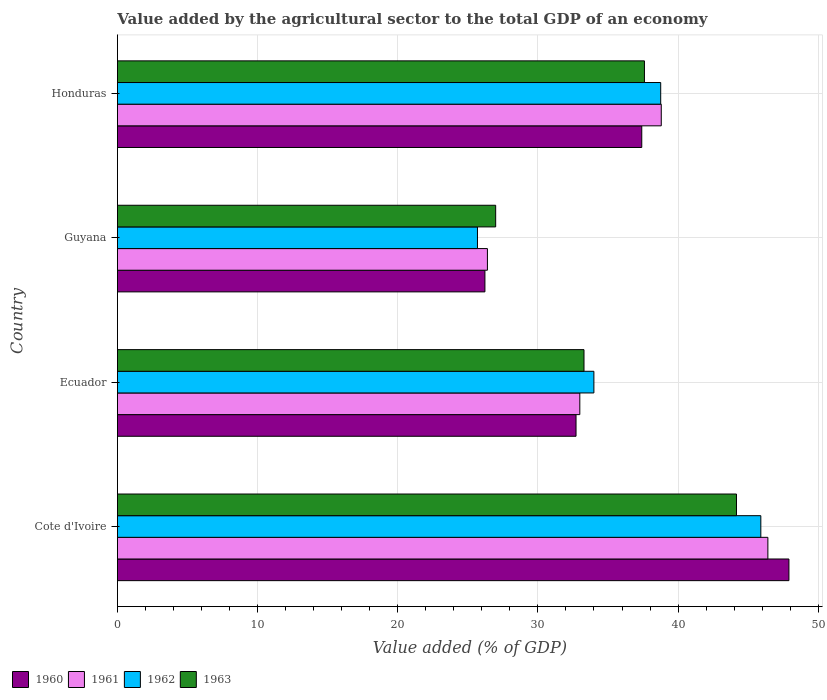How many groups of bars are there?
Ensure brevity in your answer.  4. Are the number of bars per tick equal to the number of legend labels?
Keep it short and to the point. Yes. How many bars are there on the 2nd tick from the top?
Give a very brief answer. 4. What is the label of the 4th group of bars from the top?
Ensure brevity in your answer.  Cote d'Ivoire. What is the value added by the agricultural sector to the total GDP in 1963 in Cote d'Ivoire?
Offer a very short reply. 44.17. Across all countries, what is the maximum value added by the agricultural sector to the total GDP in 1960?
Give a very brief answer. 47.91. Across all countries, what is the minimum value added by the agricultural sector to the total GDP in 1962?
Keep it short and to the point. 25.69. In which country was the value added by the agricultural sector to the total GDP in 1961 maximum?
Your answer should be compact. Cote d'Ivoire. In which country was the value added by the agricultural sector to the total GDP in 1960 minimum?
Your answer should be compact. Guyana. What is the total value added by the agricultural sector to the total GDP in 1963 in the graph?
Make the answer very short. 142.04. What is the difference between the value added by the agricultural sector to the total GDP in 1961 in Cote d'Ivoire and that in Honduras?
Your answer should be very brief. 7.61. What is the difference between the value added by the agricultural sector to the total GDP in 1960 in Honduras and the value added by the agricultural sector to the total GDP in 1963 in Ecuador?
Offer a very short reply. 4.12. What is the average value added by the agricultural sector to the total GDP in 1961 per country?
Offer a terse response. 36.15. What is the difference between the value added by the agricultural sector to the total GDP in 1963 and value added by the agricultural sector to the total GDP in 1962 in Ecuador?
Provide a succinct answer. -0.71. What is the ratio of the value added by the agricultural sector to the total GDP in 1962 in Cote d'Ivoire to that in Ecuador?
Provide a succinct answer. 1.35. Is the value added by the agricultural sector to the total GDP in 1962 in Guyana less than that in Honduras?
Provide a succinct answer. Yes. What is the difference between the highest and the second highest value added by the agricultural sector to the total GDP in 1960?
Your answer should be compact. 10.5. What is the difference between the highest and the lowest value added by the agricultural sector to the total GDP in 1963?
Give a very brief answer. 17.18. Is the sum of the value added by the agricultural sector to the total GDP in 1962 in Cote d'Ivoire and Honduras greater than the maximum value added by the agricultural sector to the total GDP in 1960 across all countries?
Make the answer very short. Yes. Is it the case that in every country, the sum of the value added by the agricultural sector to the total GDP in 1962 and value added by the agricultural sector to the total GDP in 1961 is greater than the sum of value added by the agricultural sector to the total GDP in 1963 and value added by the agricultural sector to the total GDP in 1960?
Make the answer very short. No. What does the 1st bar from the bottom in Honduras represents?
Offer a terse response. 1960. Is it the case that in every country, the sum of the value added by the agricultural sector to the total GDP in 1963 and value added by the agricultural sector to the total GDP in 1961 is greater than the value added by the agricultural sector to the total GDP in 1962?
Offer a very short reply. Yes. How many bars are there?
Your answer should be very brief. 16. How many countries are there in the graph?
Offer a very short reply. 4. Are the values on the major ticks of X-axis written in scientific E-notation?
Offer a very short reply. No. Does the graph contain any zero values?
Give a very brief answer. No. Does the graph contain grids?
Ensure brevity in your answer.  Yes. Where does the legend appear in the graph?
Ensure brevity in your answer.  Bottom left. What is the title of the graph?
Ensure brevity in your answer.  Value added by the agricultural sector to the total GDP of an economy. What is the label or title of the X-axis?
Offer a very short reply. Value added (% of GDP). What is the label or title of the Y-axis?
Ensure brevity in your answer.  Country. What is the Value added (% of GDP) in 1960 in Cote d'Ivoire?
Provide a succinct answer. 47.91. What is the Value added (% of GDP) in 1961 in Cote d'Ivoire?
Give a very brief answer. 46.41. What is the Value added (% of GDP) in 1962 in Cote d'Ivoire?
Keep it short and to the point. 45.9. What is the Value added (% of GDP) of 1963 in Cote d'Ivoire?
Make the answer very short. 44.17. What is the Value added (% of GDP) in 1960 in Ecuador?
Your answer should be very brief. 32.72. What is the Value added (% of GDP) of 1961 in Ecuador?
Provide a short and direct response. 32.99. What is the Value added (% of GDP) in 1962 in Ecuador?
Your answer should be very brief. 33.99. What is the Value added (% of GDP) of 1963 in Ecuador?
Your response must be concise. 33.29. What is the Value added (% of GDP) in 1960 in Guyana?
Provide a short and direct response. 26.22. What is the Value added (% of GDP) of 1961 in Guyana?
Your answer should be very brief. 26.4. What is the Value added (% of GDP) of 1962 in Guyana?
Make the answer very short. 25.69. What is the Value added (% of GDP) in 1963 in Guyana?
Make the answer very short. 26.99. What is the Value added (% of GDP) of 1960 in Honduras?
Offer a terse response. 37.41. What is the Value added (% of GDP) in 1961 in Honduras?
Keep it short and to the point. 38.8. What is the Value added (% of GDP) of 1962 in Honduras?
Keep it short and to the point. 38.76. What is the Value added (% of GDP) in 1963 in Honduras?
Provide a succinct answer. 37.6. Across all countries, what is the maximum Value added (% of GDP) in 1960?
Make the answer very short. 47.91. Across all countries, what is the maximum Value added (% of GDP) of 1961?
Keep it short and to the point. 46.41. Across all countries, what is the maximum Value added (% of GDP) in 1962?
Provide a short and direct response. 45.9. Across all countries, what is the maximum Value added (% of GDP) of 1963?
Make the answer very short. 44.17. Across all countries, what is the minimum Value added (% of GDP) in 1960?
Your answer should be compact. 26.22. Across all countries, what is the minimum Value added (% of GDP) of 1961?
Your answer should be compact. 26.4. Across all countries, what is the minimum Value added (% of GDP) of 1962?
Provide a succinct answer. 25.69. Across all countries, what is the minimum Value added (% of GDP) in 1963?
Provide a short and direct response. 26.99. What is the total Value added (% of GDP) of 1960 in the graph?
Make the answer very short. 144.26. What is the total Value added (% of GDP) in 1961 in the graph?
Your response must be concise. 144.6. What is the total Value added (% of GDP) in 1962 in the graph?
Provide a succinct answer. 144.35. What is the total Value added (% of GDP) of 1963 in the graph?
Offer a terse response. 142.04. What is the difference between the Value added (% of GDP) in 1960 in Cote d'Ivoire and that in Ecuador?
Offer a very short reply. 15.19. What is the difference between the Value added (% of GDP) in 1961 in Cote d'Ivoire and that in Ecuador?
Make the answer very short. 13.42. What is the difference between the Value added (% of GDP) of 1962 in Cote d'Ivoire and that in Ecuador?
Your response must be concise. 11.91. What is the difference between the Value added (% of GDP) in 1963 in Cote d'Ivoire and that in Ecuador?
Offer a terse response. 10.88. What is the difference between the Value added (% of GDP) of 1960 in Cote d'Ivoire and that in Guyana?
Keep it short and to the point. 21.69. What is the difference between the Value added (% of GDP) of 1961 in Cote d'Ivoire and that in Guyana?
Provide a succinct answer. 20.01. What is the difference between the Value added (% of GDP) in 1962 in Cote d'Ivoire and that in Guyana?
Your answer should be compact. 20.22. What is the difference between the Value added (% of GDP) in 1963 in Cote d'Ivoire and that in Guyana?
Your answer should be compact. 17.18. What is the difference between the Value added (% of GDP) in 1960 in Cote d'Ivoire and that in Honduras?
Your answer should be compact. 10.5. What is the difference between the Value added (% of GDP) in 1961 in Cote d'Ivoire and that in Honduras?
Your response must be concise. 7.61. What is the difference between the Value added (% of GDP) of 1962 in Cote d'Ivoire and that in Honduras?
Ensure brevity in your answer.  7.14. What is the difference between the Value added (% of GDP) in 1963 in Cote d'Ivoire and that in Honduras?
Provide a succinct answer. 6.57. What is the difference between the Value added (% of GDP) in 1960 in Ecuador and that in Guyana?
Ensure brevity in your answer.  6.5. What is the difference between the Value added (% of GDP) in 1961 in Ecuador and that in Guyana?
Make the answer very short. 6.59. What is the difference between the Value added (% of GDP) in 1962 in Ecuador and that in Guyana?
Give a very brief answer. 8.31. What is the difference between the Value added (% of GDP) of 1963 in Ecuador and that in Guyana?
Make the answer very short. 6.3. What is the difference between the Value added (% of GDP) in 1960 in Ecuador and that in Honduras?
Offer a very short reply. -4.69. What is the difference between the Value added (% of GDP) of 1961 in Ecuador and that in Honduras?
Your answer should be compact. -5.81. What is the difference between the Value added (% of GDP) of 1962 in Ecuador and that in Honduras?
Provide a succinct answer. -4.77. What is the difference between the Value added (% of GDP) in 1963 in Ecuador and that in Honduras?
Your response must be concise. -4.31. What is the difference between the Value added (% of GDP) of 1960 in Guyana and that in Honduras?
Give a very brief answer. -11.19. What is the difference between the Value added (% of GDP) of 1961 in Guyana and that in Honduras?
Make the answer very short. -12.4. What is the difference between the Value added (% of GDP) in 1962 in Guyana and that in Honduras?
Give a very brief answer. -13.07. What is the difference between the Value added (% of GDP) in 1963 in Guyana and that in Honduras?
Your response must be concise. -10.61. What is the difference between the Value added (% of GDP) in 1960 in Cote d'Ivoire and the Value added (% of GDP) in 1961 in Ecuador?
Offer a very short reply. 14.92. What is the difference between the Value added (% of GDP) of 1960 in Cote d'Ivoire and the Value added (% of GDP) of 1962 in Ecuador?
Your answer should be compact. 13.91. What is the difference between the Value added (% of GDP) in 1960 in Cote d'Ivoire and the Value added (% of GDP) in 1963 in Ecuador?
Your answer should be compact. 14.62. What is the difference between the Value added (% of GDP) of 1961 in Cote d'Ivoire and the Value added (% of GDP) of 1962 in Ecuador?
Your response must be concise. 12.41. What is the difference between the Value added (% of GDP) of 1961 in Cote d'Ivoire and the Value added (% of GDP) of 1963 in Ecuador?
Make the answer very short. 13.12. What is the difference between the Value added (% of GDP) in 1962 in Cote d'Ivoire and the Value added (% of GDP) in 1963 in Ecuador?
Provide a succinct answer. 12.62. What is the difference between the Value added (% of GDP) in 1960 in Cote d'Ivoire and the Value added (% of GDP) in 1961 in Guyana?
Offer a very short reply. 21.51. What is the difference between the Value added (% of GDP) of 1960 in Cote d'Ivoire and the Value added (% of GDP) of 1962 in Guyana?
Provide a succinct answer. 22.22. What is the difference between the Value added (% of GDP) in 1960 in Cote d'Ivoire and the Value added (% of GDP) in 1963 in Guyana?
Provide a short and direct response. 20.92. What is the difference between the Value added (% of GDP) in 1961 in Cote d'Ivoire and the Value added (% of GDP) in 1962 in Guyana?
Keep it short and to the point. 20.72. What is the difference between the Value added (% of GDP) of 1961 in Cote d'Ivoire and the Value added (% of GDP) of 1963 in Guyana?
Provide a short and direct response. 19.42. What is the difference between the Value added (% of GDP) of 1962 in Cote d'Ivoire and the Value added (% of GDP) of 1963 in Guyana?
Ensure brevity in your answer.  18.92. What is the difference between the Value added (% of GDP) of 1960 in Cote d'Ivoire and the Value added (% of GDP) of 1961 in Honduras?
Ensure brevity in your answer.  9.11. What is the difference between the Value added (% of GDP) in 1960 in Cote d'Ivoire and the Value added (% of GDP) in 1962 in Honduras?
Make the answer very short. 9.15. What is the difference between the Value added (% of GDP) in 1960 in Cote d'Ivoire and the Value added (% of GDP) in 1963 in Honduras?
Your response must be concise. 10.31. What is the difference between the Value added (% of GDP) of 1961 in Cote d'Ivoire and the Value added (% of GDP) of 1962 in Honduras?
Your response must be concise. 7.65. What is the difference between the Value added (% of GDP) of 1961 in Cote d'Ivoire and the Value added (% of GDP) of 1963 in Honduras?
Your answer should be compact. 8.81. What is the difference between the Value added (% of GDP) of 1962 in Cote d'Ivoire and the Value added (% of GDP) of 1963 in Honduras?
Keep it short and to the point. 8.3. What is the difference between the Value added (% of GDP) of 1960 in Ecuador and the Value added (% of GDP) of 1961 in Guyana?
Give a very brief answer. 6.32. What is the difference between the Value added (% of GDP) in 1960 in Ecuador and the Value added (% of GDP) in 1962 in Guyana?
Make the answer very short. 7.03. What is the difference between the Value added (% of GDP) in 1960 in Ecuador and the Value added (% of GDP) in 1963 in Guyana?
Keep it short and to the point. 5.73. What is the difference between the Value added (% of GDP) of 1961 in Ecuador and the Value added (% of GDP) of 1962 in Guyana?
Make the answer very short. 7.3. What is the difference between the Value added (% of GDP) of 1961 in Ecuador and the Value added (% of GDP) of 1963 in Guyana?
Give a very brief answer. 6. What is the difference between the Value added (% of GDP) in 1962 in Ecuador and the Value added (% of GDP) in 1963 in Guyana?
Ensure brevity in your answer.  7.01. What is the difference between the Value added (% of GDP) in 1960 in Ecuador and the Value added (% of GDP) in 1961 in Honduras?
Your answer should be very brief. -6.08. What is the difference between the Value added (% of GDP) of 1960 in Ecuador and the Value added (% of GDP) of 1962 in Honduras?
Provide a succinct answer. -6.04. What is the difference between the Value added (% of GDP) of 1960 in Ecuador and the Value added (% of GDP) of 1963 in Honduras?
Make the answer very short. -4.88. What is the difference between the Value added (% of GDP) in 1961 in Ecuador and the Value added (% of GDP) in 1962 in Honduras?
Your response must be concise. -5.77. What is the difference between the Value added (% of GDP) of 1961 in Ecuador and the Value added (% of GDP) of 1963 in Honduras?
Keep it short and to the point. -4.61. What is the difference between the Value added (% of GDP) of 1962 in Ecuador and the Value added (% of GDP) of 1963 in Honduras?
Keep it short and to the point. -3.61. What is the difference between the Value added (% of GDP) in 1960 in Guyana and the Value added (% of GDP) in 1961 in Honduras?
Keep it short and to the point. -12.58. What is the difference between the Value added (% of GDP) in 1960 in Guyana and the Value added (% of GDP) in 1962 in Honduras?
Offer a very short reply. -12.54. What is the difference between the Value added (% of GDP) in 1960 in Guyana and the Value added (% of GDP) in 1963 in Honduras?
Keep it short and to the point. -11.38. What is the difference between the Value added (% of GDP) in 1961 in Guyana and the Value added (% of GDP) in 1962 in Honduras?
Offer a very short reply. -12.36. What is the difference between the Value added (% of GDP) of 1961 in Guyana and the Value added (% of GDP) of 1963 in Honduras?
Your answer should be very brief. -11.2. What is the difference between the Value added (% of GDP) in 1962 in Guyana and the Value added (% of GDP) in 1963 in Honduras?
Offer a terse response. -11.91. What is the average Value added (% of GDP) of 1960 per country?
Offer a terse response. 36.06. What is the average Value added (% of GDP) in 1961 per country?
Make the answer very short. 36.15. What is the average Value added (% of GDP) in 1962 per country?
Offer a terse response. 36.09. What is the average Value added (% of GDP) of 1963 per country?
Offer a terse response. 35.51. What is the difference between the Value added (% of GDP) of 1960 and Value added (% of GDP) of 1961 in Cote d'Ivoire?
Provide a short and direct response. 1.5. What is the difference between the Value added (% of GDP) of 1960 and Value added (% of GDP) of 1962 in Cote d'Ivoire?
Give a very brief answer. 2. What is the difference between the Value added (% of GDP) in 1960 and Value added (% of GDP) in 1963 in Cote d'Ivoire?
Give a very brief answer. 3.74. What is the difference between the Value added (% of GDP) of 1961 and Value added (% of GDP) of 1962 in Cote d'Ivoire?
Your answer should be very brief. 0.5. What is the difference between the Value added (% of GDP) of 1961 and Value added (% of GDP) of 1963 in Cote d'Ivoire?
Provide a short and direct response. 2.24. What is the difference between the Value added (% of GDP) in 1962 and Value added (% of GDP) in 1963 in Cote d'Ivoire?
Offer a terse response. 1.74. What is the difference between the Value added (% of GDP) of 1960 and Value added (% of GDP) of 1961 in Ecuador?
Make the answer very short. -0.27. What is the difference between the Value added (% of GDP) in 1960 and Value added (% of GDP) in 1962 in Ecuador?
Your response must be concise. -1.27. What is the difference between the Value added (% of GDP) in 1960 and Value added (% of GDP) in 1963 in Ecuador?
Your answer should be very brief. -0.57. What is the difference between the Value added (% of GDP) of 1961 and Value added (% of GDP) of 1962 in Ecuador?
Offer a terse response. -1. What is the difference between the Value added (% of GDP) of 1961 and Value added (% of GDP) of 1963 in Ecuador?
Your answer should be compact. -0.3. What is the difference between the Value added (% of GDP) of 1962 and Value added (% of GDP) of 1963 in Ecuador?
Your answer should be compact. 0.71. What is the difference between the Value added (% of GDP) of 1960 and Value added (% of GDP) of 1961 in Guyana?
Provide a succinct answer. -0.18. What is the difference between the Value added (% of GDP) of 1960 and Value added (% of GDP) of 1962 in Guyana?
Provide a succinct answer. 0.53. What is the difference between the Value added (% of GDP) of 1960 and Value added (% of GDP) of 1963 in Guyana?
Provide a short and direct response. -0.77. What is the difference between the Value added (% of GDP) of 1961 and Value added (% of GDP) of 1962 in Guyana?
Keep it short and to the point. 0.71. What is the difference between the Value added (% of GDP) of 1961 and Value added (% of GDP) of 1963 in Guyana?
Make the answer very short. -0.59. What is the difference between the Value added (% of GDP) in 1962 and Value added (% of GDP) in 1963 in Guyana?
Your response must be concise. -1.3. What is the difference between the Value added (% of GDP) in 1960 and Value added (% of GDP) in 1961 in Honduras?
Make the answer very short. -1.39. What is the difference between the Value added (% of GDP) of 1960 and Value added (% of GDP) of 1962 in Honduras?
Make the answer very short. -1.35. What is the difference between the Value added (% of GDP) in 1960 and Value added (% of GDP) in 1963 in Honduras?
Your answer should be very brief. -0.19. What is the difference between the Value added (% of GDP) of 1961 and Value added (% of GDP) of 1962 in Honduras?
Your response must be concise. 0.04. What is the difference between the Value added (% of GDP) of 1961 and Value added (% of GDP) of 1963 in Honduras?
Provide a succinct answer. 1.2. What is the difference between the Value added (% of GDP) in 1962 and Value added (% of GDP) in 1963 in Honduras?
Your answer should be very brief. 1.16. What is the ratio of the Value added (% of GDP) of 1960 in Cote d'Ivoire to that in Ecuador?
Your response must be concise. 1.46. What is the ratio of the Value added (% of GDP) of 1961 in Cote d'Ivoire to that in Ecuador?
Your answer should be very brief. 1.41. What is the ratio of the Value added (% of GDP) in 1962 in Cote d'Ivoire to that in Ecuador?
Your response must be concise. 1.35. What is the ratio of the Value added (% of GDP) in 1963 in Cote d'Ivoire to that in Ecuador?
Offer a terse response. 1.33. What is the ratio of the Value added (% of GDP) in 1960 in Cote d'Ivoire to that in Guyana?
Offer a very short reply. 1.83. What is the ratio of the Value added (% of GDP) of 1961 in Cote d'Ivoire to that in Guyana?
Your answer should be compact. 1.76. What is the ratio of the Value added (% of GDP) in 1962 in Cote d'Ivoire to that in Guyana?
Your answer should be compact. 1.79. What is the ratio of the Value added (% of GDP) of 1963 in Cote d'Ivoire to that in Guyana?
Your response must be concise. 1.64. What is the ratio of the Value added (% of GDP) in 1960 in Cote d'Ivoire to that in Honduras?
Your answer should be compact. 1.28. What is the ratio of the Value added (% of GDP) of 1961 in Cote d'Ivoire to that in Honduras?
Offer a terse response. 1.2. What is the ratio of the Value added (% of GDP) in 1962 in Cote d'Ivoire to that in Honduras?
Ensure brevity in your answer.  1.18. What is the ratio of the Value added (% of GDP) in 1963 in Cote d'Ivoire to that in Honduras?
Your answer should be compact. 1.17. What is the ratio of the Value added (% of GDP) in 1960 in Ecuador to that in Guyana?
Keep it short and to the point. 1.25. What is the ratio of the Value added (% of GDP) in 1961 in Ecuador to that in Guyana?
Ensure brevity in your answer.  1.25. What is the ratio of the Value added (% of GDP) in 1962 in Ecuador to that in Guyana?
Your answer should be compact. 1.32. What is the ratio of the Value added (% of GDP) of 1963 in Ecuador to that in Guyana?
Your answer should be compact. 1.23. What is the ratio of the Value added (% of GDP) of 1960 in Ecuador to that in Honduras?
Your answer should be compact. 0.87. What is the ratio of the Value added (% of GDP) in 1961 in Ecuador to that in Honduras?
Make the answer very short. 0.85. What is the ratio of the Value added (% of GDP) of 1962 in Ecuador to that in Honduras?
Make the answer very short. 0.88. What is the ratio of the Value added (% of GDP) in 1963 in Ecuador to that in Honduras?
Make the answer very short. 0.89. What is the ratio of the Value added (% of GDP) of 1960 in Guyana to that in Honduras?
Your answer should be compact. 0.7. What is the ratio of the Value added (% of GDP) in 1961 in Guyana to that in Honduras?
Keep it short and to the point. 0.68. What is the ratio of the Value added (% of GDP) of 1962 in Guyana to that in Honduras?
Give a very brief answer. 0.66. What is the ratio of the Value added (% of GDP) in 1963 in Guyana to that in Honduras?
Provide a short and direct response. 0.72. What is the difference between the highest and the second highest Value added (% of GDP) in 1960?
Provide a succinct answer. 10.5. What is the difference between the highest and the second highest Value added (% of GDP) of 1961?
Provide a short and direct response. 7.61. What is the difference between the highest and the second highest Value added (% of GDP) in 1962?
Your answer should be compact. 7.14. What is the difference between the highest and the second highest Value added (% of GDP) in 1963?
Provide a succinct answer. 6.57. What is the difference between the highest and the lowest Value added (% of GDP) of 1960?
Keep it short and to the point. 21.69. What is the difference between the highest and the lowest Value added (% of GDP) in 1961?
Keep it short and to the point. 20.01. What is the difference between the highest and the lowest Value added (% of GDP) of 1962?
Keep it short and to the point. 20.22. What is the difference between the highest and the lowest Value added (% of GDP) of 1963?
Provide a short and direct response. 17.18. 